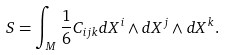Convert formula to latex. <formula><loc_0><loc_0><loc_500><loc_500>S = \int _ { M } \frac { 1 } { 6 } C _ { i j k } d X ^ { i } \wedge d X ^ { j } \wedge d X ^ { k } .</formula> 